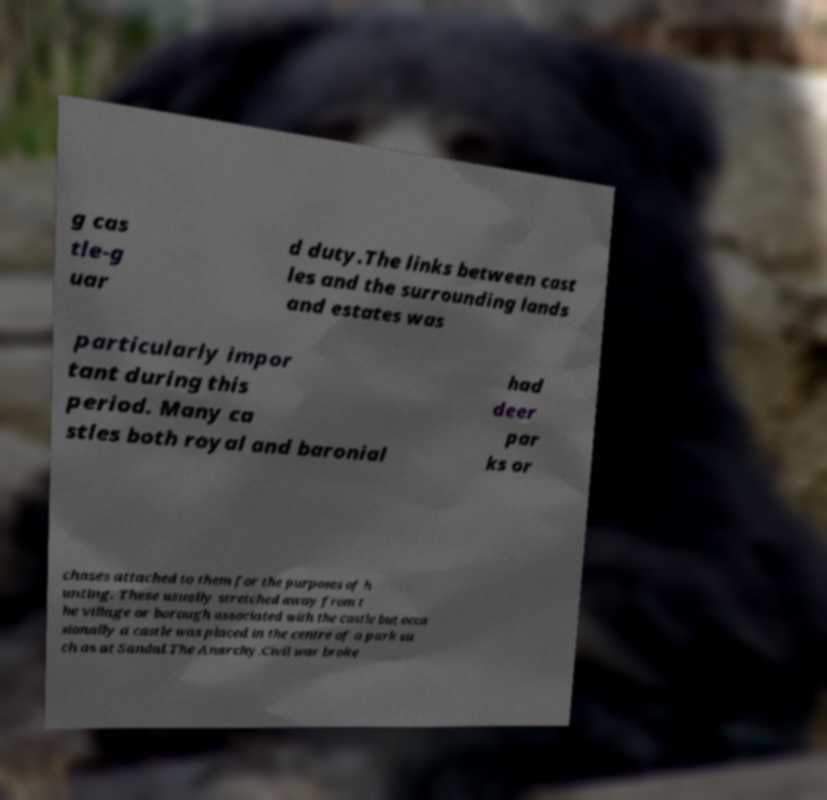I need the written content from this picture converted into text. Can you do that? g cas tle-g uar d duty.The links between cast les and the surrounding lands and estates was particularly impor tant during this period. Many ca stles both royal and baronial had deer par ks or chases attached to them for the purposes of h unting. These usually stretched away from t he village or borough associated with the castle but occa sionally a castle was placed in the centre of a park su ch as at Sandal.The Anarchy.Civil war broke 